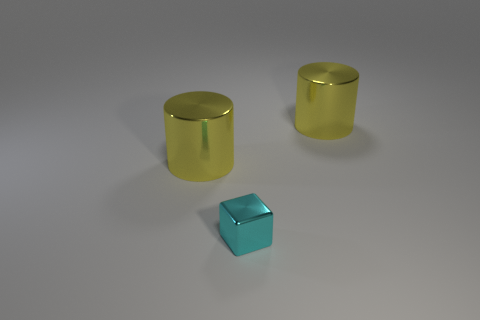Are there any other things that have the same shape as the cyan shiny thing?
Provide a short and direct response. No. There is a yellow thing that is right of the small cyan object; are there any large yellow things in front of it?
Your answer should be compact. Yes. What number of cylinders have the same color as the tiny metallic block?
Offer a very short reply. 0. There is a large metallic thing that is behind the large metallic thing that is in front of the large yellow metallic cylinder on the right side of the small cyan metal thing; what color is it?
Offer a very short reply. Yellow. What number of large cylinders are the same material as the small block?
Offer a terse response. 2. There is a cylinder right of the tiny object; is its color the same as the small shiny cube?
Your response must be concise. No. How many large shiny things are the same shape as the tiny metallic object?
Keep it short and to the point. 0. Is the number of cyan metal cubes behind the cyan block the same as the number of large gray cylinders?
Give a very brief answer. Yes. Is there another small cyan metal object of the same shape as the cyan metal thing?
Ensure brevity in your answer.  No. There is a big cylinder that is left of the large thing on the right side of the cylinder to the left of the cyan block; what is its material?
Your response must be concise. Metal. 